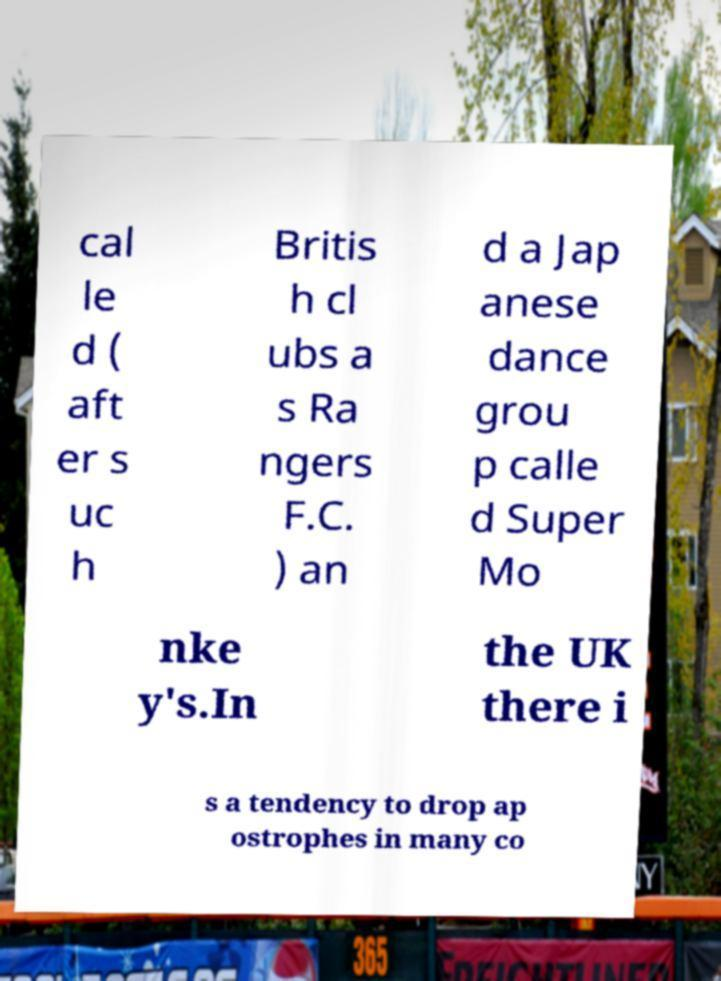Can you accurately transcribe the text from the provided image for me? cal le d ( aft er s uc h Britis h cl ubs a s Ra ngers F.C. ) an d a Jap anese dance grou p calle d Super Mo nke y's.In the UK there i s a tendency to drop ap ostrophes in many co 